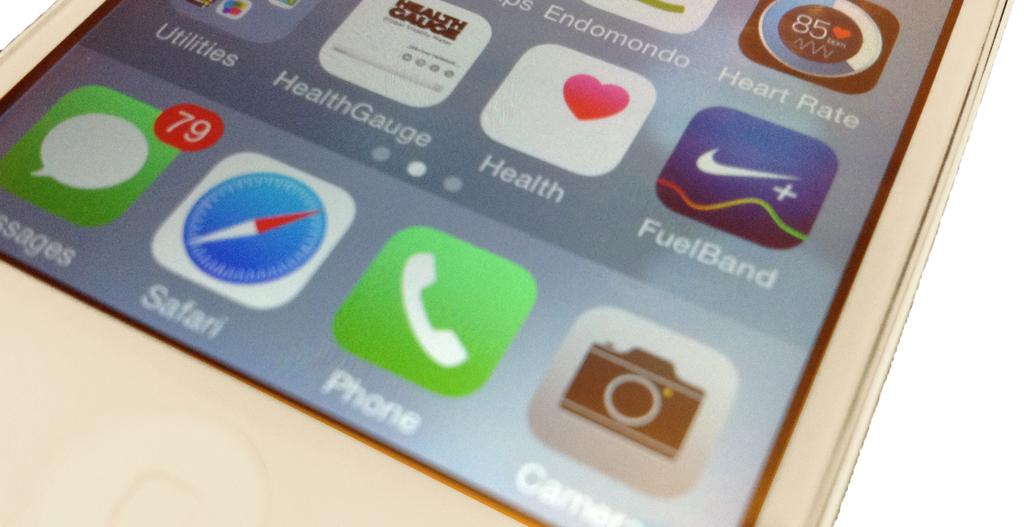<image>
Summarize the visual content of the image. An iphone that has apps like FuelBand, Health Gauge, and Heart Rate on it. 